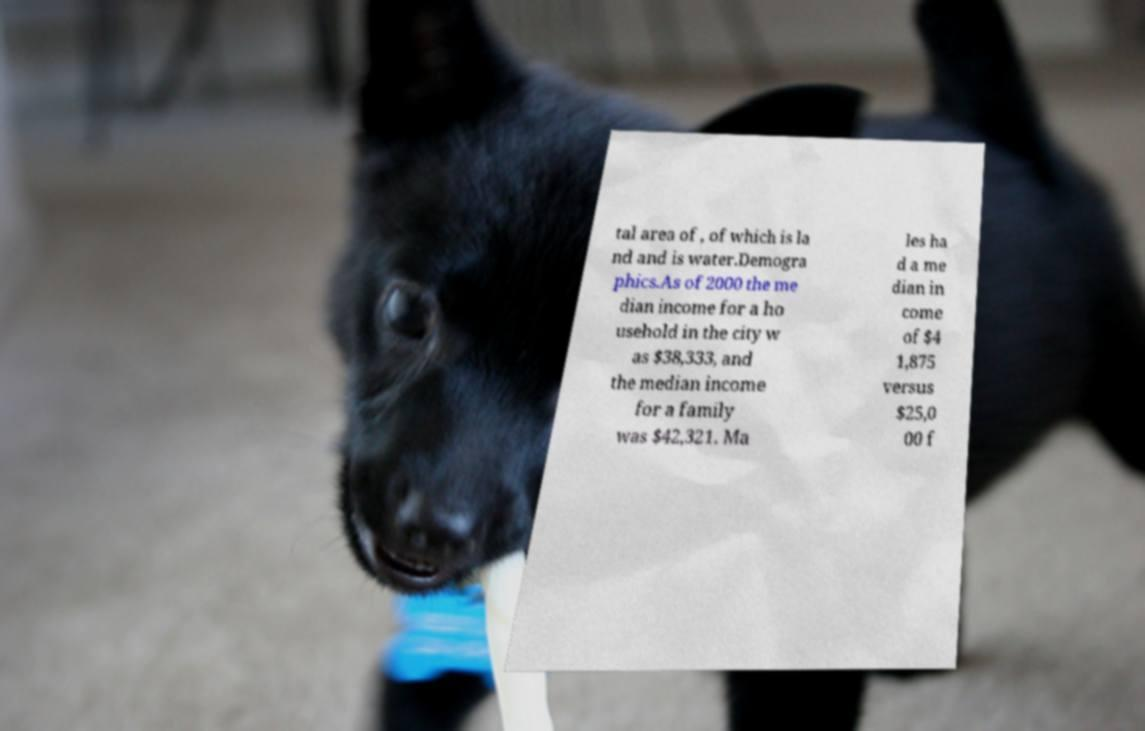For documentation purposes, I need the text within this image transcribed. Could you provide that? tal area of , of which is la nd and is water.Demogra phics.As of 2000 the me dian income for a ho usehold in the city w as $38,333, and the median income for a family was $42,321. Ma les ha d a me dian in come of $4 1,875 versus $25,0 00 f 